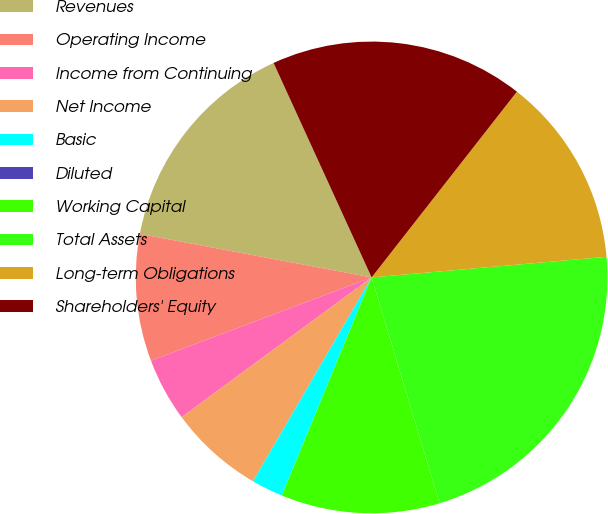Convert chart to OTSL. <chart><loc_0><loc_0><loc_500><loc_500><pie_chart><fcel>Revenues<fcel>Operating Income<fcel>Income from Continuing<fcel>Net Income<fcel>Basic<fcel>Diluted<fcel>Working Capital<fcel>Total Assets<fcel>Long-term Obligations<fcel>Shareholders' Equity<nl><fcel>15.22%<fcel>8.7%<fcel>4.35%<fcel>6.52%<fcel>2.17%<fcel>0.0%<fcel>10.87%<fcel>21.74%<fcel>13.04%<fcel>17.39%<nl></chart> 